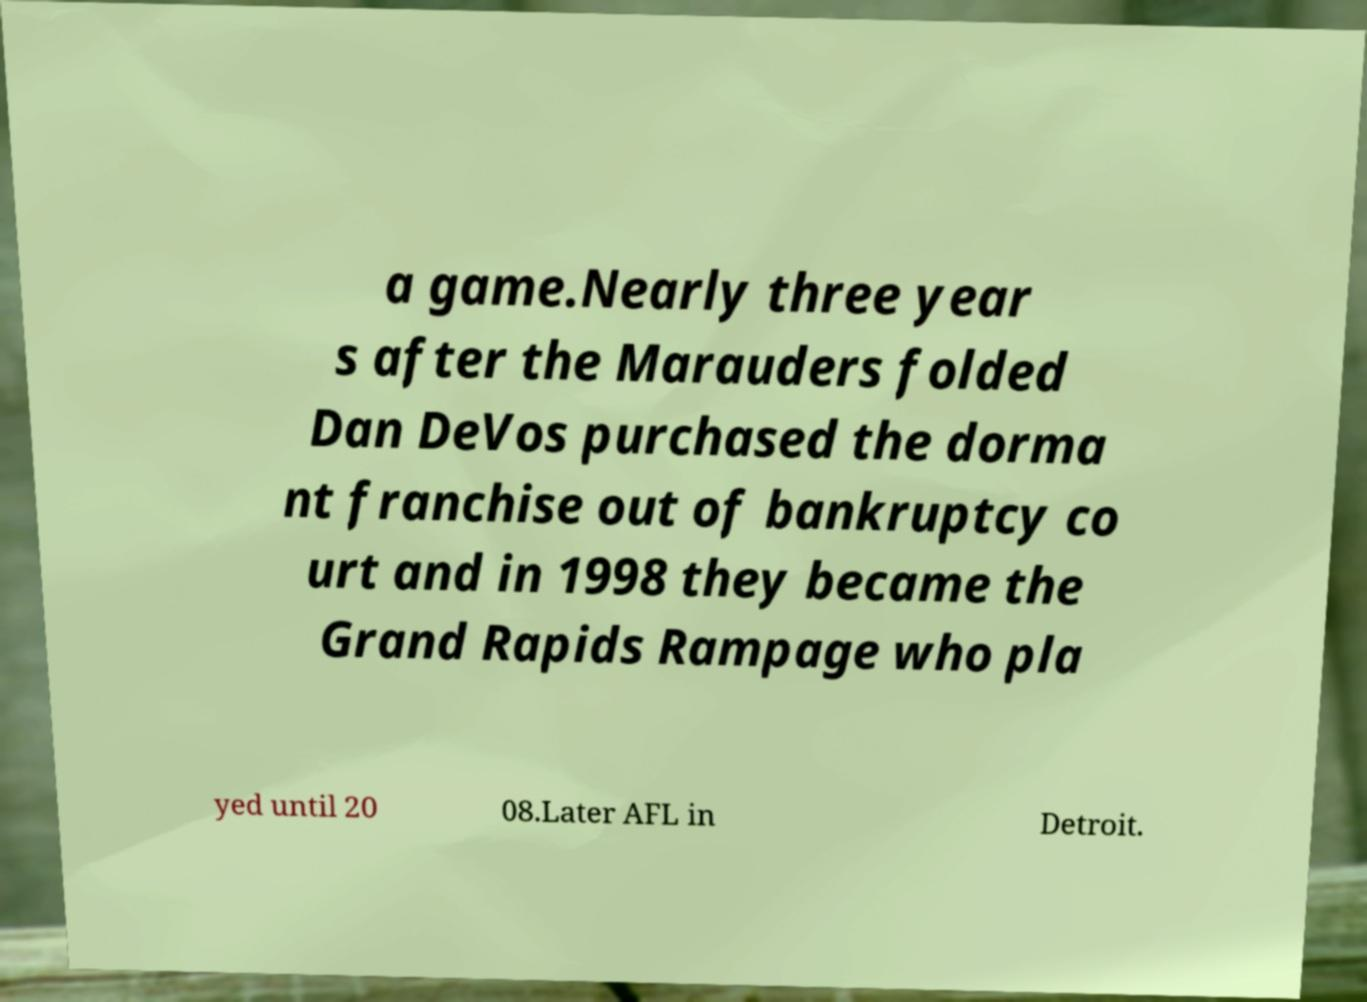Could you assist in decoding the text presented in this image and type it out clearly? a game.Nearly three year s after the Marauders folded Dan DeVos purchased the dorma nt franchise out of bankruptcy co urt and in 1998 they became the Grand Rapids Rampage who pla yed until 20 08.Later AFL in Detroit. 